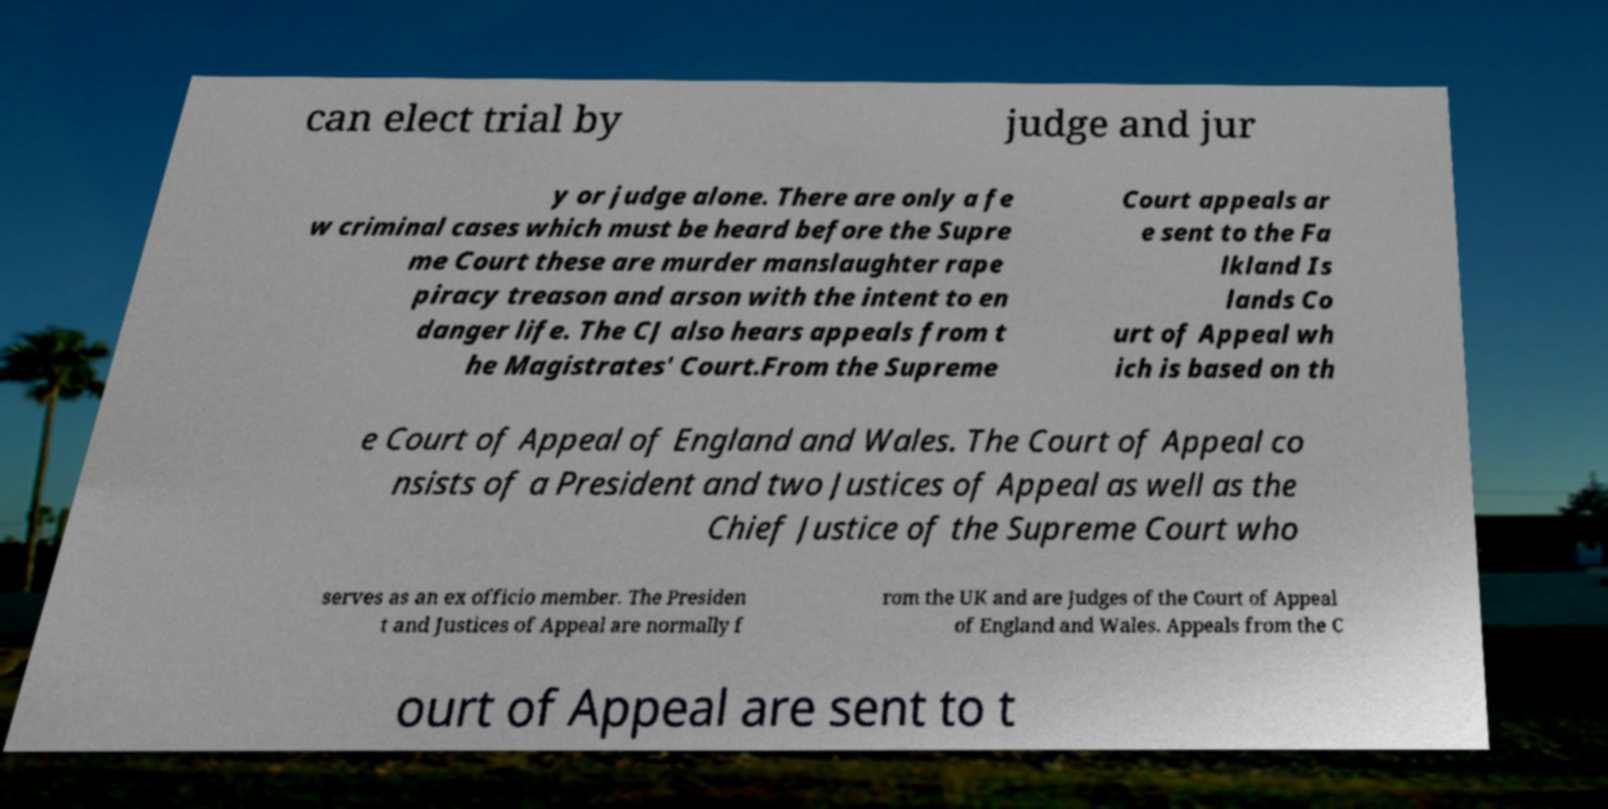Can you accurately transcribe the text from the provided image for me? can elect trial by judge and jur y or judge alone. There are only a fe w criminal cases which must be heard before the Supre me Court these are murder manslaughter rape piracy treason and arson with the intent to en danger life. The CJ also hears appeals from t he Magistrates' Court.From the Supreme Court appeals ar e sent to the Fa lkland Is lands Co urt of Appeal wh ich is based on th e Court of Appeal of England and Wales. The Court of Appeal co nsists of a President and two Justices of Appeal as well as the Chief Justice of the Supreme Court who serves as an ex officio member. The Presiden t and Justices of Appeal are normally f rom the UK and are Judges of the Court of Appeal of England and Wales. Appeals from the C ourt of Appeal are sent to t 